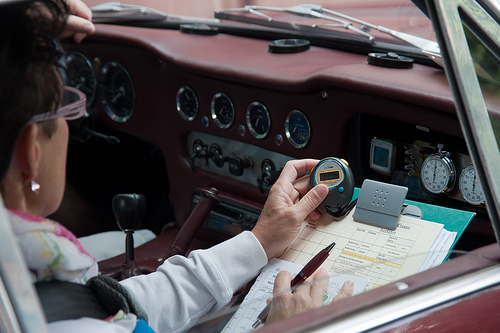Describe the overall theme or activity visible in this image. The image captures an older woman possibly participating in a vintage car rally, meticulously documenting times or measurements while seated in an antique car. 